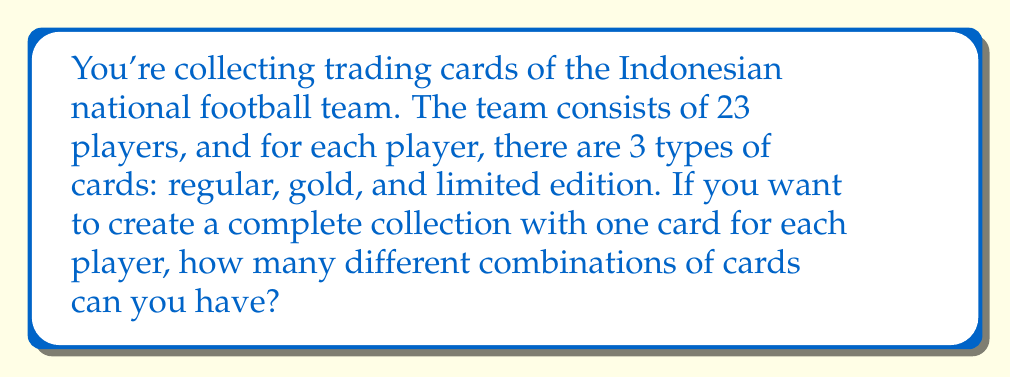Can you answer this question? Let's approach this step-by-step:

1) We have 23 players in the team.

2) For each player, we have 3 choices of cards (regular, gold, or limited edition).

3) For each player, we make an independent choice of which card type to include in our collection.

4) This scenario follows the multiplication principle of counting.

5) For each player, we have 3 choices, and we make this choice 23 times (once for each player).

6) Therefore, the total number of possible combinations is:

   $$3^{23}$$

7) To calculate this:
   $$3^{23} = 3 \times 3 \times 3 \times ... \times 3$$ (23 times)
   
   $$= 94,143,178,827$$

Thus, there are 94,143,178,827 different possible combinations for a complete collection.
Answer: $3^{23} = 94,143,178,827$ 